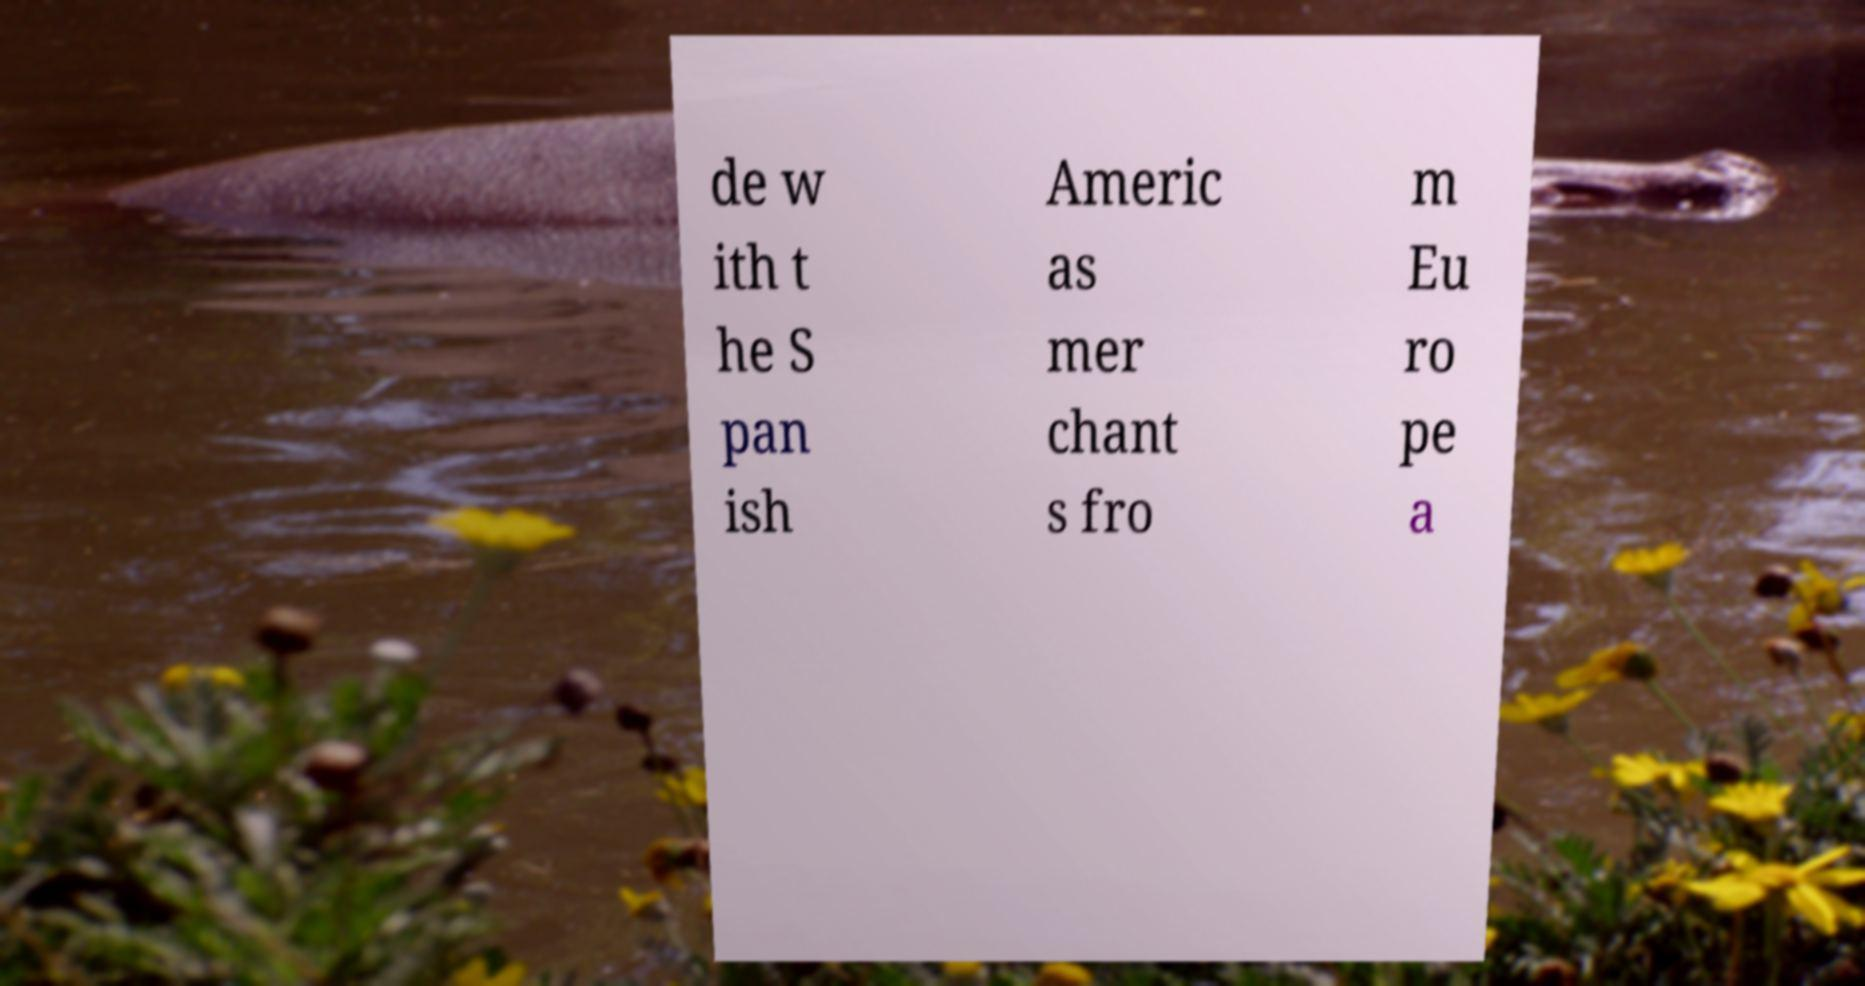Can you read and provide the text displayed in the image?This photo seems to have some interesting text. Can you extract and type it out for me? de w ith t he S pan ish Americ as mer chant s fro m Eu ro pe a 